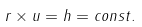Convert formula to latex. <formula><loc_0><loc_0><loc_500><loc_500>r \times u = h = c o n s t .</formula> 